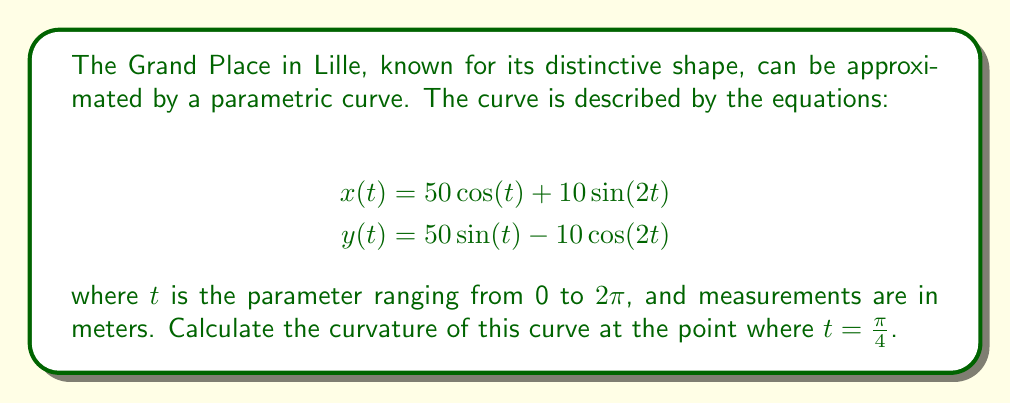Teach me how to tackle this problem. To find the curvature of a parametric curve at a given point, we'll use the formula:

$$\kappa = \frac{|x'y'' - y'x''|}{(x'^2 + y'^2)^{3/2}}$$

where $x'$ and $y'$ are the first derivatives, and $x''$ and $y''$ are the second derivatives with respect to $t$.

Step 1: Calculate the first derivatives
$$x'(t) = -50\sin(t) + 20\cos(2t)$$
$$y'(t) = 50\cos(t) + 20\sin(2t)$$

Step 2: Calculate the second derivatives
$$x''(t) = -50\cos(t) - 40\sin(2t)$$
$$y''(t) = -50\sin(t) + 40\cos(2t)$$

Step 3: Evaluate the derivatives at $t = \frac{\pi}{4}$
$$x'(\frac{\pi}{4}) = -50\sin(\frac{\pi}{4}) + 20\cos(\frac{\pi}{2}) = -\frac{50}{\sqrt{2}}$$
$$y'(\frac{\pi}{4}) = 50\cos(\frac{\pi}{4}) + 20\sin(\frac{\pi}{2}) = \frac{50}{\sqrt{2}} + 20$$
$$x''(\frac{\pi}{4}) = -50\cos(\frac{\pi}{4}) - 40\sin(\frac{\pi}{2}) = -\frac{50}{\sqrt{2}} - 40$$
$$y''(\frac{\pi}{4}) = -50\sin(\frac{\pi}{4}) + 40\cos(\frac{\pi}{2}) = -\frac{50}{\sqrt{2}}$$

Step 4: Calculate the numerator of the curvature formula
$$|x'y'' - y'x''| = |\left(-\frac{50}{\sqrt{2}}\right)\left(-\frac{50}{\sqrt{2}}\right) - \left(\frac{50}{\sqrt{2}} + 20\right)\left(-\frac{50}{\sqrt{2}} - 40\right)|$$
$$= \left|\frac{2500}{2} + \frac{2500}{2} + 1000\sqrt{2} + 2000\right| = 2500 + 1000\sqrt{2} + 2000 = 4500 + 1000\sqrt{2}$$

Step 5: Calculate the denominator of the curvature formula
$$(x'^2 + y'^2)^{3/2} = \left(\left(-\frac{50}{\sqrt{2}}\right)^2 + \left(\frac{50}{\sqrt{2}} + 20\right)^2\right)^{3/2}$$
$$= \left(\frac{2500}{2} + \frac{2500}{2} + 2000\sqrt{2} + 400\right)^{3/2} = (2900 + 2000\sqrt{2})^{3/2}$$

Step 6: Calculate the final curvature
$$\kappa = \frac{4500 + 1000\sqrt{2}}{(2900 + 2000\sqrt{2})^{3/2}}$$
Answer: The curvature of the parametric curve describing the shape of Lille's Grand Place at $t = \frac{\pi}{4}$ is:

$$\kappa = \frac{4500 + 1000\sqrt{2}}{(2900 + 2000\sqrt{2})^{3/2}} \approx 0.0152 \text{ m}^{-1}$$ 